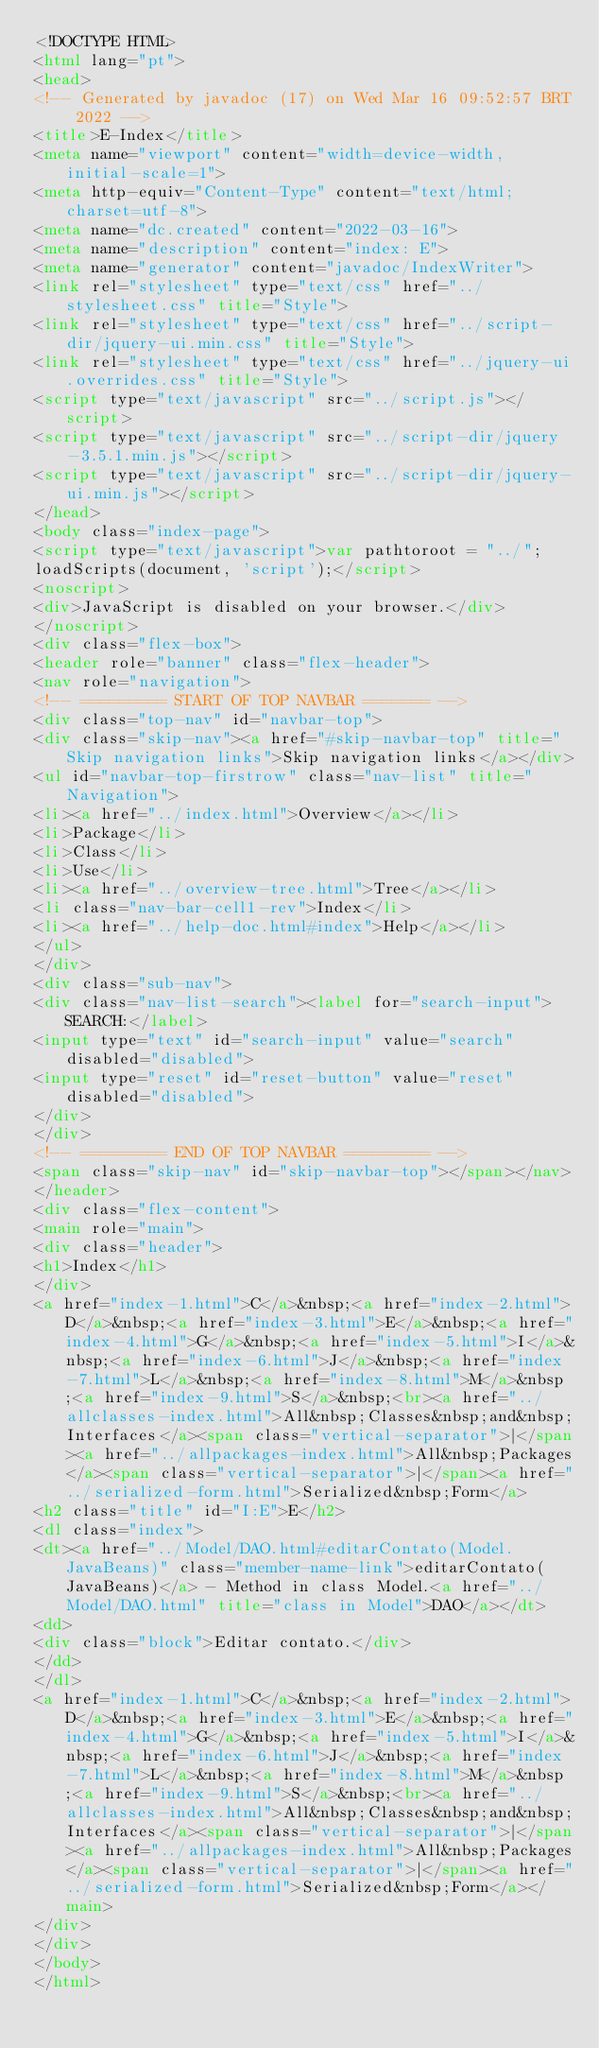<code> <loc_0><loc_0><loc_500><loc_500><_HTML_><!DOCTYPE HTML>
<html lang="pt">
<head>
<!-- Generated by javadoc (17) on Wed Mar 16 09:52:57 BRT 2022 -->
<title>E-Index</title>
<meta name="viewport" content="width=device-width, initial-scale=1">
<meta http-equiv="Content-Type" content="text/html; charset=utf-8">
<meta name="dc.created" content="2022-03-16">
<meta name="description" content="index: E">
<meta name="generator" content="javadoc/IndexWriter">
<link rel="stylesheet" type="text/css" href="../stylesheet.css" title="Style">
<link rel="stylesheet" type="text/css" href="../script-dir/jquery-ui.min.css" title="Style">
<link rel="stylesheet" type="text/css" href="../jquery-ui.overrides.css" title="Style">
<script type="text/javascript" src="../script.js"></script>
<script type="text/javascript" src="../script-dir/jquery-3.5.1.min.js"></script>
<script type="text/javascript" src="../script-dir/jquery-ui.min.js"></script>
</head>
<body class="index-page">
<script type="text/javascript">var pathtoroot = "../";
loadScripts(document, 'script');</script>
<noscript>
<div>JavaScript is disabled on your browser.</div>
</noscript>
<div class="flex-box">
<header role="banner" class="flex-header">
<nav role="navigation">
<!-- ========= START OF TOP NAVBAR ======= -->
<div class="top-nav" id="navbar-top">
<div class="skip-nav"><a href="#skip-navbar-top" title="Skip navigation links">Skip navigation links</a></div>
<ul id="navbar-top-firstrow" class="nav-list" title="Navigation">
<li><a href="../index.html">Overview</a></li>
<li>Package</li>
<li>Class</li>
<li>Use</li>
<li><a href="../overview-tree.html">Tree</a></li>
<li class="nav-bar-cell1-rev">Index</li>
<li><a href="../help-doc.html#index">Help</a></li>
</ul>
</div>
<div class="sub-nav">
<div class="nav-list-search"><label for="search-input">SEARCH:</label>
<input type="text" id="search-input" value="search" disabled="disabled">
<input type="reset" id="reset-button" value="reset" disabled="disabled">
</div>
</div>
<!-- ========= END OF TOP NAVBAR ========= -->
<span class="skip-nav" id="skip-navbar-top"></span></nav>
</header>
<div class="flex-content">
<main role="main">
<div class="header">
<h1>Index</h1>
</div>
<a href="index-1.html">C</a>&nbsp;<a href="index-2.html">D</a>&nbsp;<a href="index-3.html">E</a>&nbsp;<a href="index-4.html">G</a>&nbsp;<a href="index-5.html">I</a>&nbsp;<a href="index-6.html">J</a>&nbsp;<a href="index-7.html">L</a>&nbsp;<a href="index-8.html">M</a>&nbsp;<a href="index-9.html">S</a>&nbsp;<br><a href="../allclasses-index.html">All&nbsp;Classes&nbsp;and&nbsp;Interfaces</a><span class="vertical-separator">|</span><a href="../allpackages-index.html">All&nbsp;Packages</a><span class="vertical-separator">|</span><a href="../serialized-form.html">Serialized&nbsp;Form</a>
<h2 class="title" id="I:E">E</h2>
<dl class="index">
<dt><a href="../Model/DAO.html#editarContato(Model.JavaBeans)" class="member-name-link">editarContato(JavaBeans)</a> - Method in class Model.<a href="../Model/DAO.html" title="class in Model">DAO</a></dt>
<dd>
<div class="block">Editar contato.</div>
</dd>
</dl>
<a href="index-1.html">C</a>&nbsp;<a href="index-2.html">D</a>&nbsp;<a href="index-3.html">E</a>&nbsp;<a href="index-4.html">G</a>&nbsp;<a href="index-5.html">I</a>&nbsp;<a href="index-6.html">J</a>&nbsp;<a href="index-7.html">L</a>&nbsp;<a href="index-8.html">M</a>&nbsp;<a href="index-9.html">S</a>&nbsp;<br><a href="../allclasses-index.html">All&nbsp;Classes&nbsp;and&nbsp;Interfaces</a><span class="vertical-separator">|</span><a href="../allpackages-index.html">All&nbsp;Packages</a><span class="vertical-separator">|</span><a href="../serialized-form.html">Serialized&nbsp;Form</a></main>
</div>
</div>
</body>
</html>
</code> 